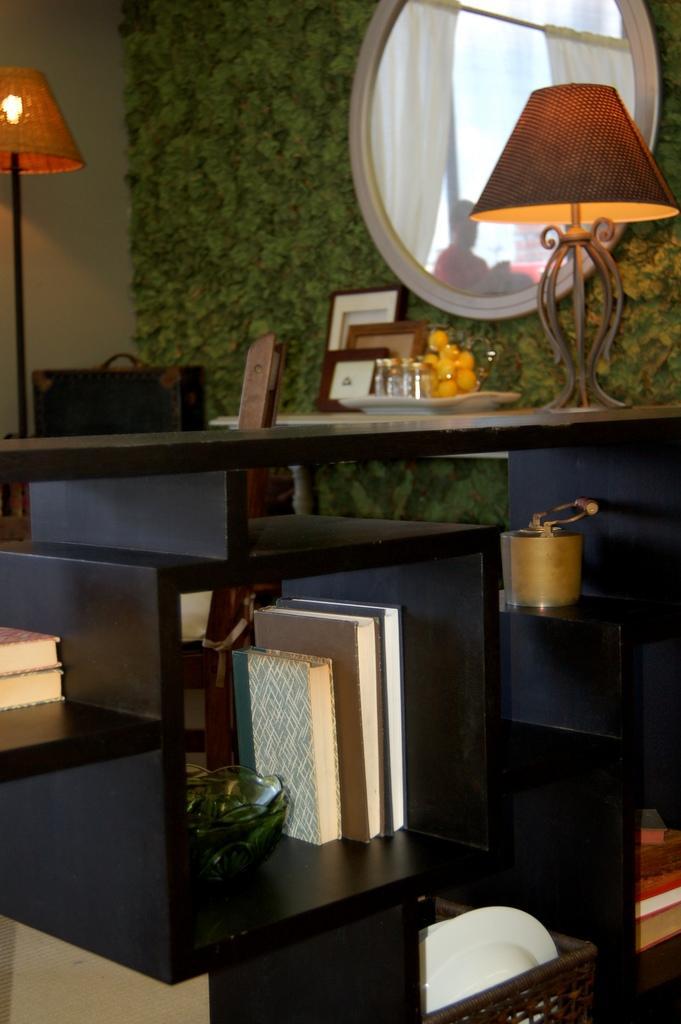Please provide a concise description of this image. The picture is taken in a room. In the foreground of the picture there is a bookshelf, in the shelf there are books, bowl, plates and other objects. At the top there are lamps, briefcase, frames, glasses, mirror and other objects. 